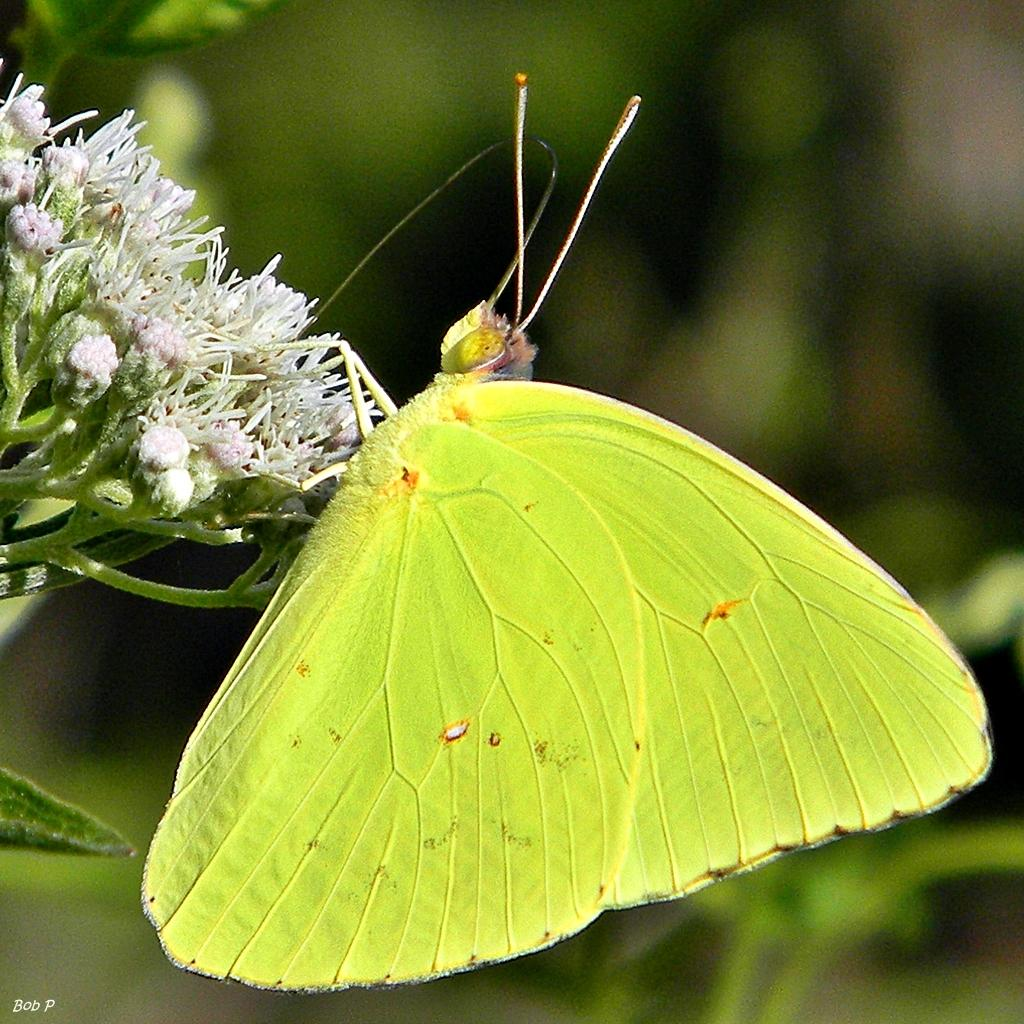What is the main subject of the image? There is a butterfly in the image. Where is the butterfly located in the image? The butterfly is on a flower. What is the color of the butterfly? The butterfly is green in color. What type of bait is the butterfly using to catch fish in the image? There is no bait or fish present in the image; it features a green butterfly on a flower. 